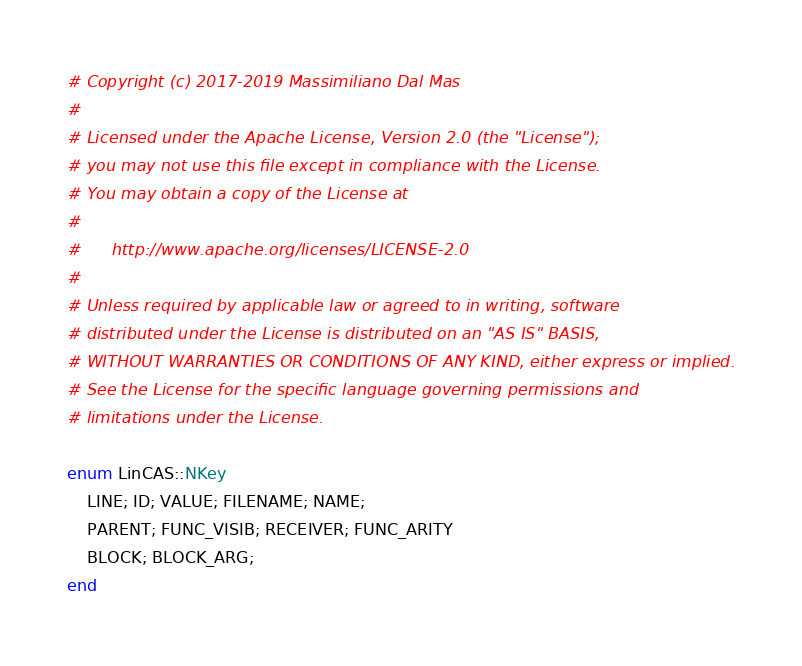<code> <loc_0><loc_0><loc_500><loc_500><_Crystal_>
# Copyright (c) 2017-2019 Massimiliano Dal Mas
#
# Licensed under the Apache License, Version 2.0 (the "License");
# you may not use this file except in compliance with the License.
# You may obtain a copy of the License at
#
#      http://www.apache.org/licenses/LICENSE-2.0
#
# Unless required by applicable law or agreed to in writing, software
# distributed under the License is distributed on an "AS IS" BASIS,
# WITHOUT WARRANTIES OR CONDITIONS OF ANY KIND, either express or implied.
# See the License for the specific language governing permissions and
# limitations under the License.

enum LinCAS::NKey
    LINE; ID; VALUE; FILENAME; NAME;
    PARENT; FUNC_VISIB; RECEIVER; FUNC_ARITY
    BLOCK; BLOCK_ARG;
end
</code> 